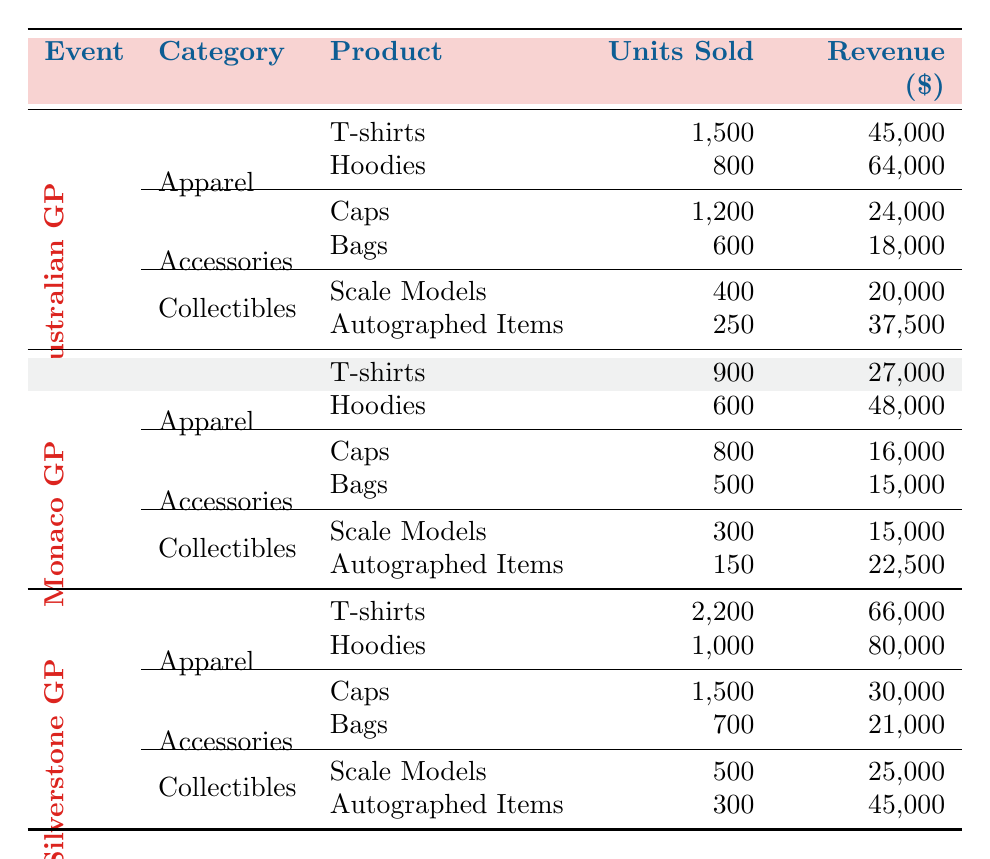How many T-shirts were sold at the Silverstone Grand Prix? The Silverstone Grand Prix section lists T-shirts under Apparel, showing that 2,200 units were sold.
Answer: 2,200 What is the total revenue from merchandise sales at the Australian Grand Prix? The table lists the revenue for each item sold at the Australian Grand Prix: T-shirts ($45,000), Hoodies ($64,000), Caps ($24,000), Bags ($18,000), Scale Models ($20,000), and Autographed Items ($37,500). Adding these amounts gives a total revenue of $45,000 + $64,000 + $24,000 + $18,000 + $20,000 + $37,500 = $208,500.
Answer: $208,500 Did more Caps or Bags sell at the Monaco Grand Prix? In the Monaco Grand Prix section: Caps sold 800 units and Bags sold 500 units. Since 800 is greater than 500, more Caps sold.
Answer: Yes What product category had the highest revenue at the Silverstone Grand Prix? The revenue for each category at Silverstone is: Apparel ($66,000 + $80,000 = $146,000), Accessories ($30,000 + $21,000 = $51,000), and Collectibles ($25,000 + $45,000 = $70,000). Apparel has the highest total revenue at $146,000.
Answer: Apparel How many more Hoodies were sold at the Australian Grand Prix compared to the Monaco Grand Prix? At the Australian Grand Prix, 800 Hoodies were sold and at the Monaco Grand Prix, 600 Hoodies were sold. The difference is 800 - 600 = 200.
Answer: 200 What was the total number of units sold for all Collectibles across all events? For Collectibles, the numbers are: Australian Grand Prix (400 + 250 = 650), Monaco Grand Prix (300 + 150 = 450), and Silverstone Grand Prix (500 + 300 = 800). The total is 650 + 450 + 800 = 1900 units sold for Collectibles.
Answer: 1900 Which Grand Prix had the highest sales of Autographed Items? The revenue indicates the number of units sold for Autographed Items are: Australian Grand Prix (250), Monaco Grand Prix (150), and Silverstone Grand Prix (300). Comparing these numbers, Silverstone Grand Prix, with 300 units, had the highest sales.
Answer: Silverstone Grand Prix What is the average revenue from Bags sold across all Grand Prix events? The table shows Bags revenue: Australian Grand Prix ($18,000), Monaco Grand Prix ($15,000), and Silverstone Grand Prix ($21,000). The total revenue for Bags is $18,000 + $15,000 + $21,000 = $54,000, and there are 3 events. The average is $54,000 / 3 = $18,000.
Answer: $18,000 